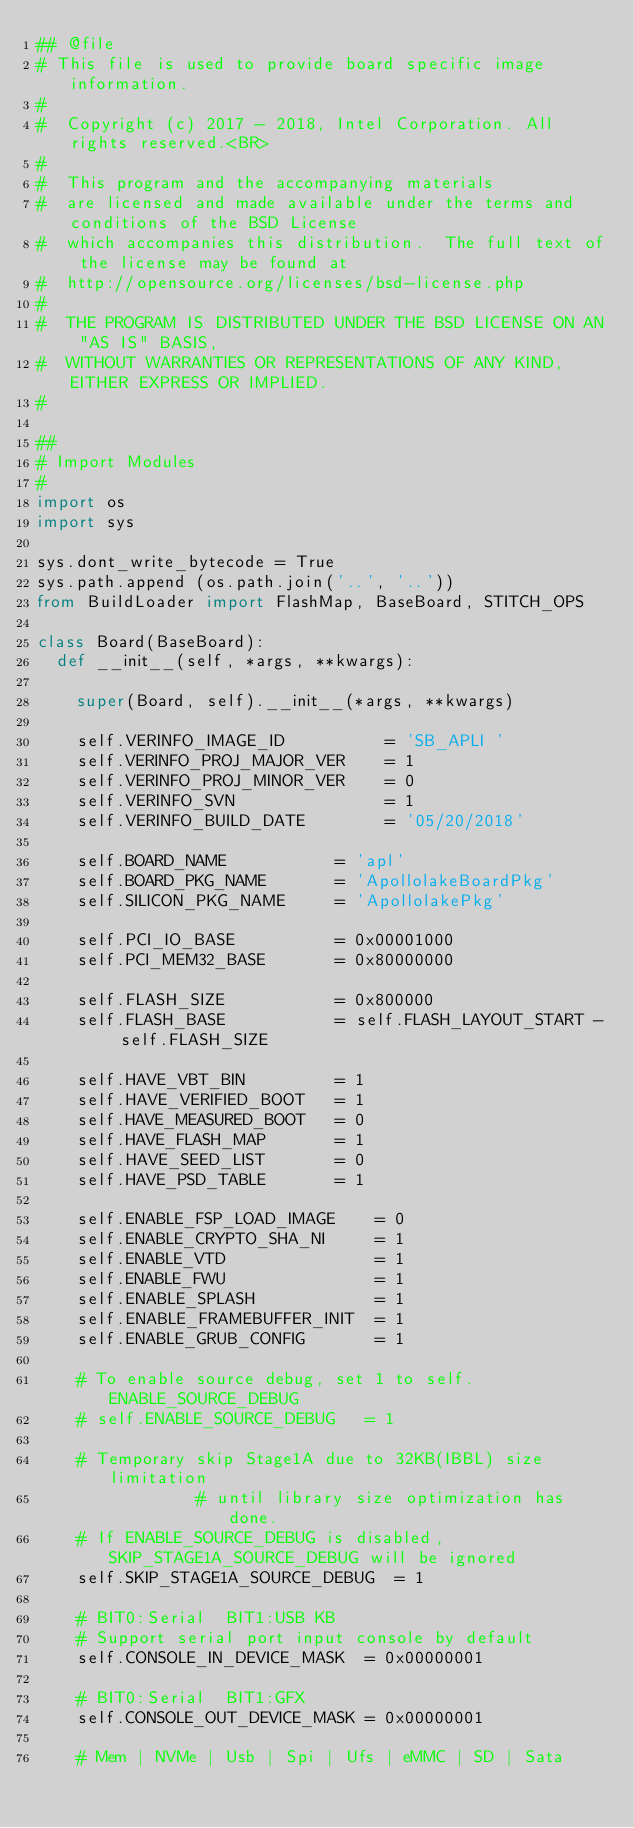<code> <loc_0><loc_0><loc_500><loc_500><_Python_>## @file
# This file is used to provide board specific image information.
#
#  Copyright (c) 2017 - 2018, Intel Corporation. All rights reserved.<BR>
#
#  This program and the accompanying materials
#  are licensed and made available under the terms and conditions of the BSD License
#  which accompanies this distribution.  The full text of the license may be found at
#  http://opensource.org/licenses/bsd-license.php
#
#  THE PROGRAM IS DISTRIBUTED UNDER THE BSD LICENSE ON AN "AS IS" BASIS,
#  WITHOUT WARRANTIES OR REPRESENTATIONS OF ANY KIND, EITHER EXPRESS OR IMPLIED.
#

##
# Import Modules
#
import os
import sys

sys.dont_write_bytecode = True
sys.path.append (os.path.join('..', '..'))
from BuildLoader import FlashMap, BaseBoard, STITCH_OPS

class Board(BaseBoard):
	def __init__(self, *args, **kwargs):

		super(Board, self).__init__(*args, **kwargs)

		self.VERINFO_IMAGE_ID          = 'SB_APLI '
		self.VERINFO_PROJ_MAJOR_VER    = 1
		self.VERINFO_PROJ_MINOR_VER    = 0
		self.VERINFO_SVN               = 1
		self.VERINFO_BUILD_DATE        = '05/20/2018'

		self.BOARD_NAME           = 'apl'
		self.BOARD_PKG_NAME       = 'ApollolakeBoardPkg'
		self.SILICON_PKG_NAME     = 'ApollolakePkg'

		self.PCI_IO_BASE          = 0x00001000
		self.PCI_MEM32_BASE       = 0x80000000

		self.FLASH_SIZE           = 0x800000
		self.FLASH_BASE           = self.FLASH_LAYOUT_START - self.FLASH_SIZE

		self.HAVE_VBT_BIN         = 1
		self.HAVE_VERIFIED_BOOT   = 1
		self.HAVE_MEASURED_BOOT   = 0
		self.HAVE_FLASH_MAP       = 1
		self.HAVE_SEED_LIST       = 0
		self.HAVE_PSD_TABLE       = 1

		self.ENABLE_FSP_LOAD_IMAGE    = 0
		self.ENABLE_CRYPTO_SHA_NI     = 1
		self.ENABLE_VTD               = 1
		self.ENABLE_FWU               = 1
		self.ENABLE_SPLASH            = 1
		self.ENABLE_FRAMEBUFFER_INIT  = 1
		self.ENABLE_GRUB_CONFIG       = 1

		# To enable source debug, set 1 to self.ENABLE_SOURCE_DEBUG
		# self.ENABLE_SOURCE_DEBUG   = 1

		# Temporary skip Stage1A due to 32KB(IBBL) size limitation
                # until library size optimization has done.
		# If ENABLE_SOURCE_DEBUG is disabled, SKIP_STAGE1A_SOURCE_DEBUG will be ignored
		self.SKIP_STAGE1A_SOURCE_DEBUG  = 1

		# BIT0:Serial  BIT1:USB KB
		# Support serial port input console by default
		self.CONSOLE_IN_DEVICE_MASK  = 0x00000001

		# BIT0:Serial  BIT1:GFX
		self.CONSOLE_OUT_DEVICE_MASK = 0x00000001

		# Mem | NVMe | Usb | Spi | Ufs | eMMC | SD | Sata</code> 